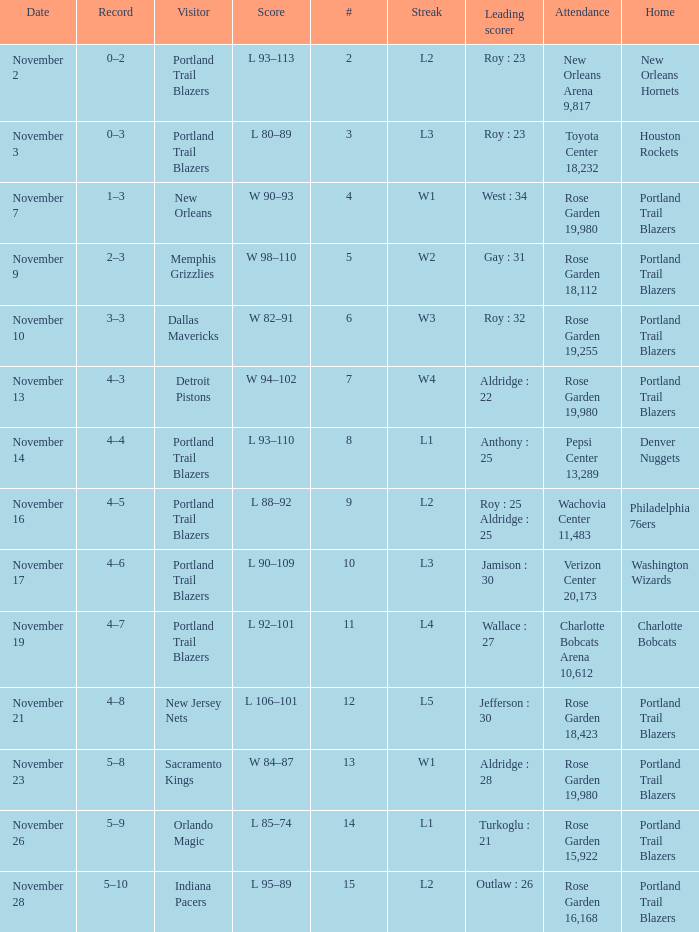 what's the home team where streak is l3 and leading scorer is roy : 23 Houston Rockets. 